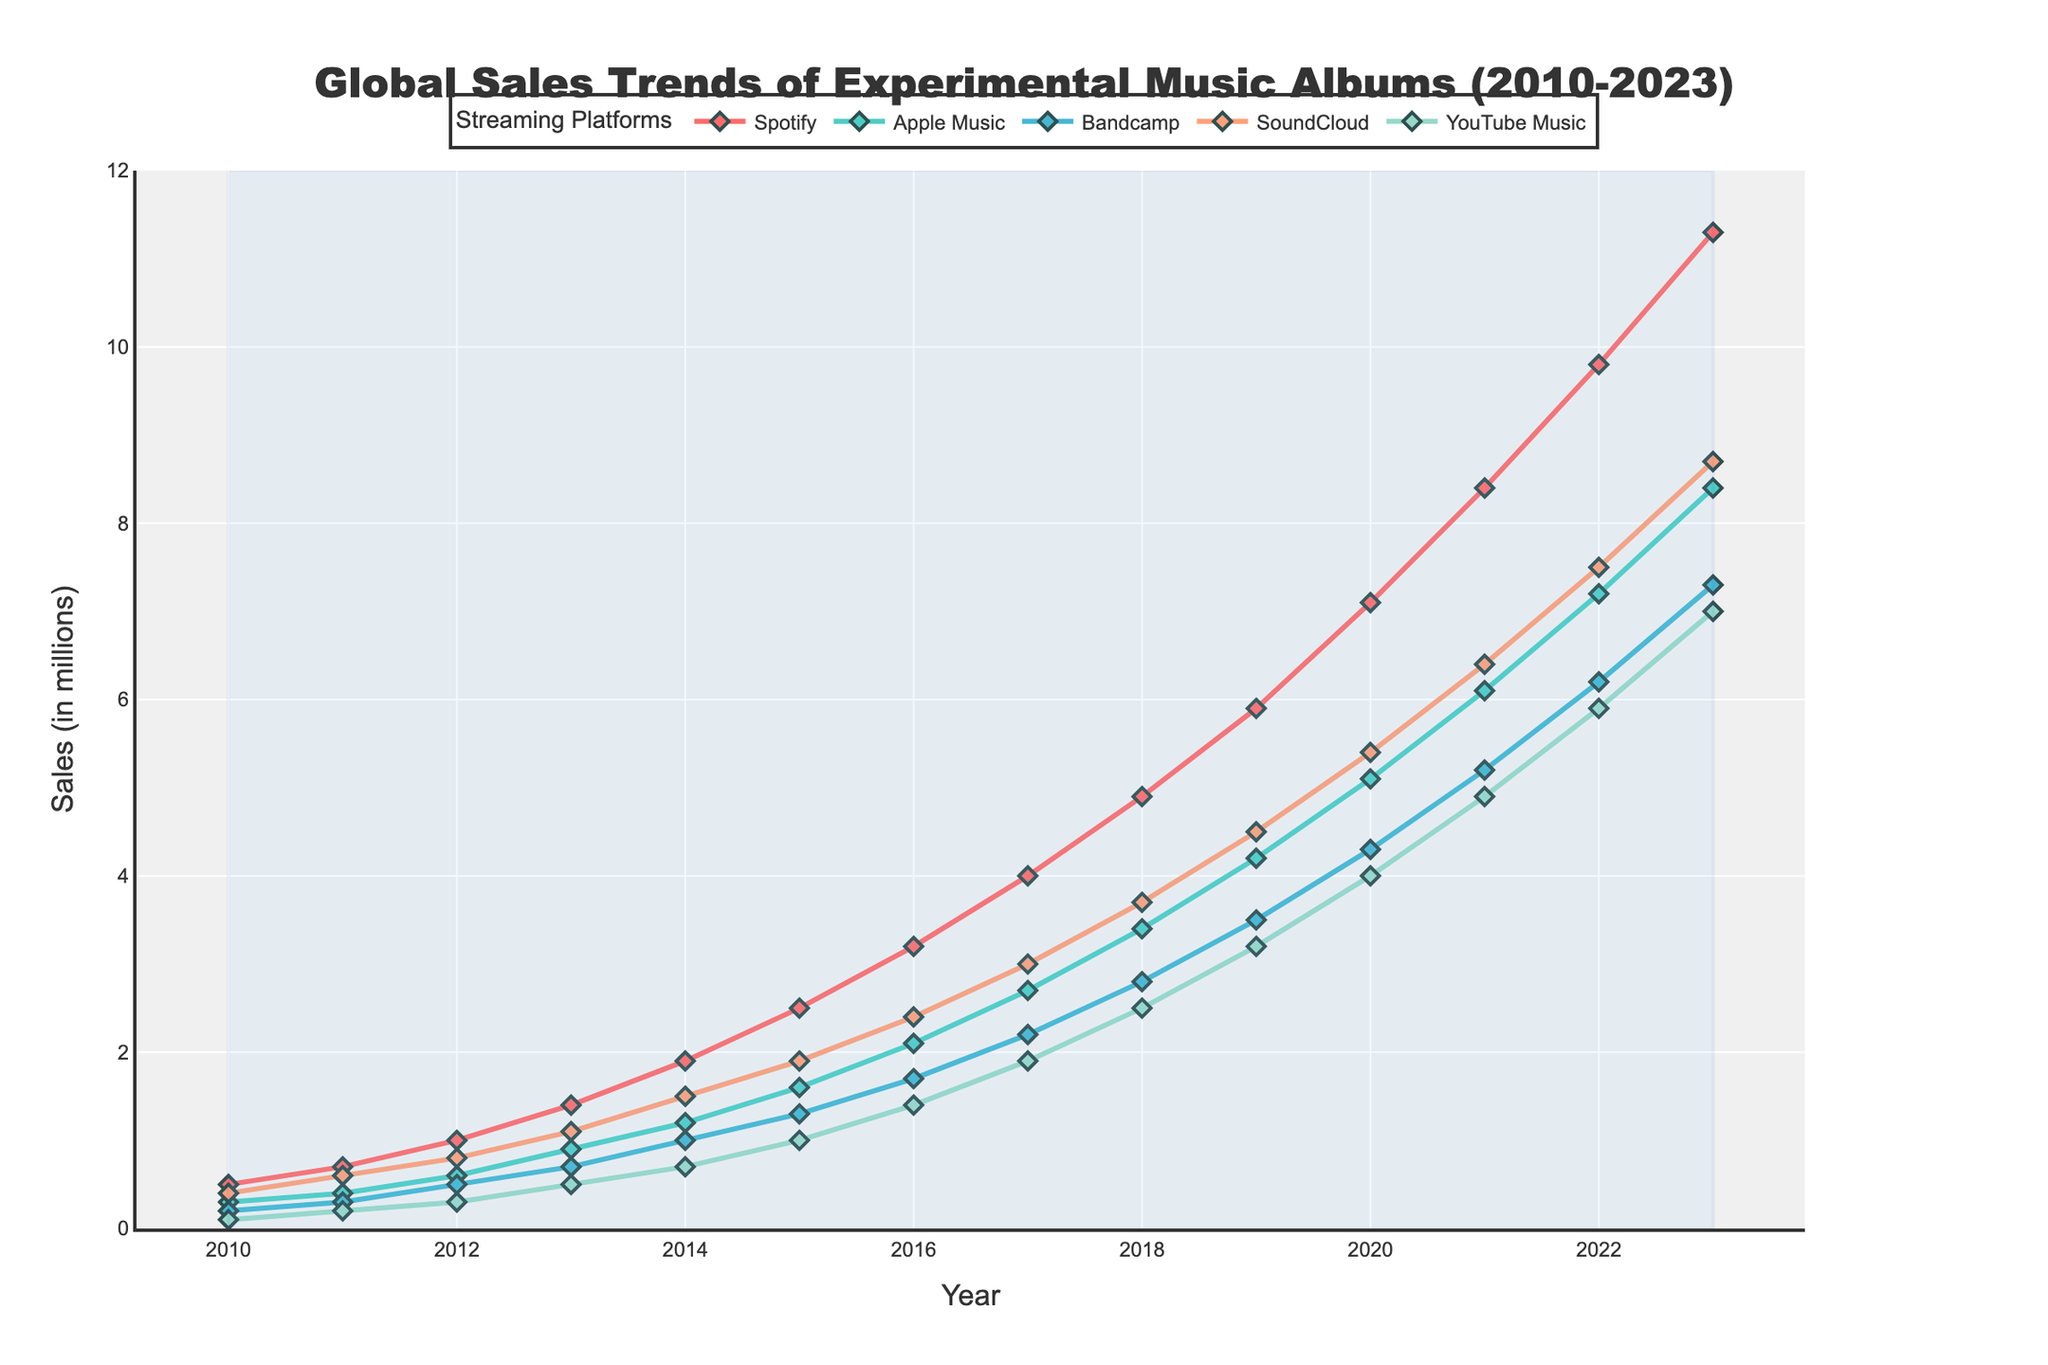How did the sales on Spotify change from 2010 to 2023? From the graph, you can see the line representing Spotify sales starts at 0.5 million in 2010 and rises to 11.3 million in 2023. The change can be calculated as 11.3 - 0.5 = 10.8 million.
Answer: Increased by 10.8 million Which platform had the highest sales growth from 2010 to 2023? By comparing the final sales values in 2023 with the initial values in 2010 for each platform, Spotify grew from 0.5 to 11.3 million, Apple Music from 0.3 to 8.4 million, Bandcamp from 0.2 to 7.3 million, SoundCloud from 0.4 to 8.7 million, and YouTube Music from 0.1 to 7.0 million. Spotify had the highest growth.
Answer: Spotify In which year did Apple Music overtake Bandcamp in sales? Observing the lines representing Apple Music and Bandcamp, Apple Music sales surpass Bandcamp sales around 2014.
Answer: 2014 What is the difference between YouTube Music's sales and SoundCloud's sales in 2021? In 2021, the sales for YouTube Music are 4.9 million and for SoundCloud are 6.4 million. The difference is 6.4 - 4.9 = 1.5 million.
Answer: 1.5 million What trend is visible across all platforms from 2010 to 2023? By looking at the lines for all platforms, you can see that sales for each platform consistently increase over the years. This indicates an overall upward trend in sales of experimental music albums.
Answer: Upward trend Which platform showed the most consistent sales growth every year from 2010 to 2023? Examining the smoothness and upward slope of the lines, Spotify's line shows the most consistent growth without any dips or fluctuations.
Answer: Spotify How much were the combined sales for all platforms in 2016? Adding the sales values of all platforms in 2016: Spotify (3.2) + Apple Music (2.1) + Bandcamp (1.7) + SoundCloud (2.4) + YouTube Music (1.4) = 10.8 million.
Answer: 10.8 million What is the average sales figure for Bandcamp from 2010 to 2023? Summing the sales values for Bandcamp from 2010 to 2023 and dividing by the number of years (14): (0.2 + 0.3 + 0.5 + 0.7 + 1.0 + 1.3 + 1.7 + 2.2 + 2.8 + 3.5 + 4.3 + 5.2 + 6.2 + 7.3) / 14 ≈ 2.89 million.
Answer: Approximately 2.89 million During which period did SoundCloud sales grow the most rapidly? Observing the slope of the SoundCloud sales line, the steepest increase appears between 2018 and 2020, indicating the most rapid growth during this period.
Answer: 2018-2020 How do the sales trends of YouTube Music compare to those of Spotify over the years? YouTube Music and Spotify both show growth over the years, but Spotify's growth is significantly more rapid and consistent, leading to higher sales by the end. YouTube Music starts lower and remains the lowest among the platforms until 2017.
Answer: Slower and lower growth compared to Spotify 